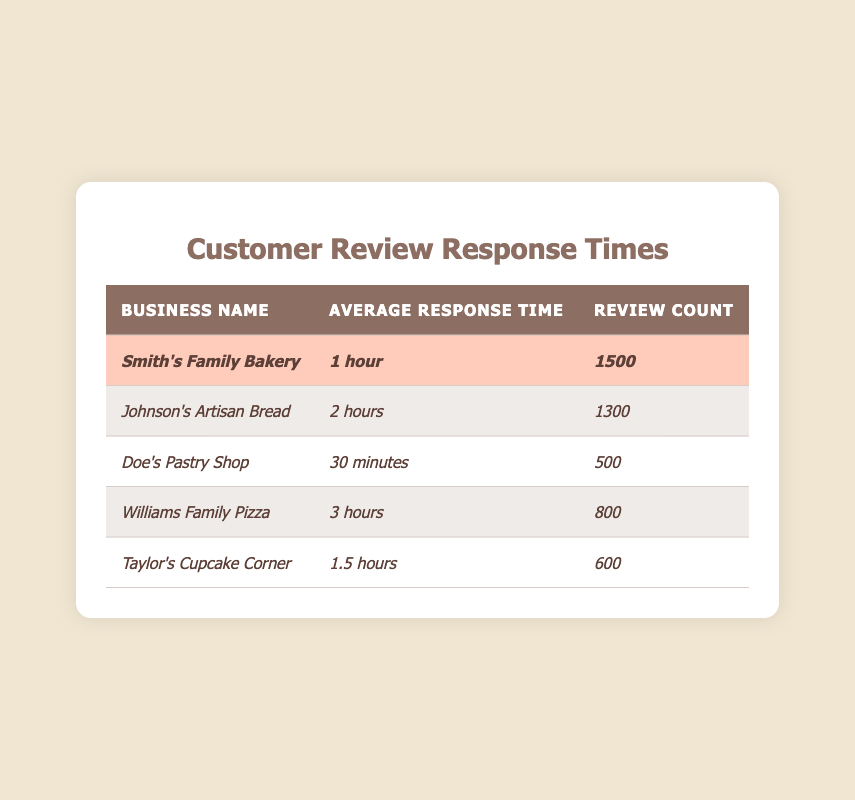What is the average response time for Smith's Family Bakery? The table lists Smith's Family Bakery's average response time, which is presented in the second column, showing "1 hour."
Answer: 1 hour Which competitor has the fastest average response time? The table lists the average response times for each business. By comparing these times, "Doe's Pastry Shop" has the quickest average response time at "30 minutes."
Answer: Doe's Pastry Shop How many reviews does Taylor's Cupcake Corner have? The number of reviews for Taylor's Cupcake Corner can be found in the third column of the table, which states it has "600" reviews.
Answer: 600 What is the difference in average response time between Smith's Family Bakery and Johnson's Artisan Bread? Smith's Family Bakery has "1 hour," and Johnson's Artisan Bread has "2 hours." The difference is 2 hours - 1 hour = 1 hour.
Answer: 1 hour Is Smith's Family Bakery's average response time better than that of Williams Family Pizza? The average response time for Smith's Family Bakery is "1 hour," while Williams Family Pizza's is "3 hours." Since 1 hour is less than 3 hours, yes, it is better.
Answer: Yes What is the total number of reviews for all listed businesses? Adding up the review counts: 1500 (Smith's) + 1300 (Johnson's) + 500 (Doe's) + 800 (Williams) + 600 (Taylor's) gives a total of 1500 + 1300 + 500 + 800 + 600 = 3700.
Answer: 3700 What is the average response time of all competitors combined? The average response time is calculated by converting each time into minutes: Johnson's Artisan Bread (120 mins), Doe's Pastry Shop (30 mins), Williams Family Pizza (180 mins), and Taylor's Cupcake Corner (90 mins). Then sum these times: 120 + 30 + 180 + 90 = 420 minutes. Divide by 4 (the number of competitors) gives us 420/4 = 105 minutes or 1 hour and 45 minutes.
Answer: 1 hour and 45 minutes Which business has the most reviews, and what is that number? Looking at the review counts across the businesses, Smith's Family Bakery has the highest count at "1500."
Answer: Smith's Family Bakery, 1500 